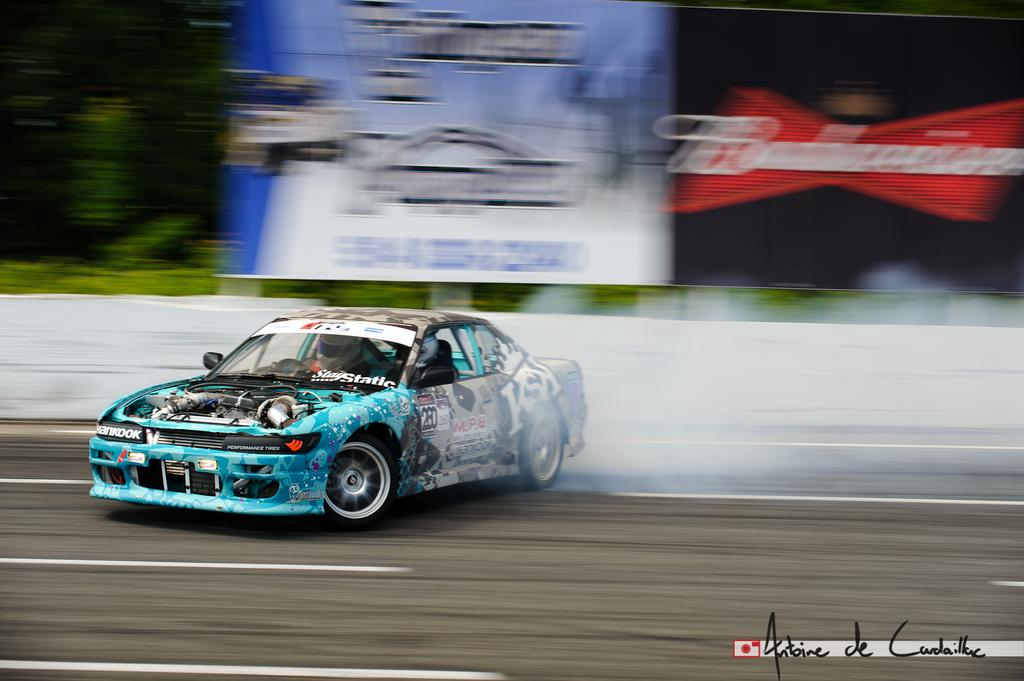What is the main subject of the image? The main subject of the image is a road. What is happening on the road? There is a person riding a car on the road. What can be seen in the background of the image? There are hoardings visible in the background. What type of natural elements are present in the image? There are trees present in the image. Where is the road located in the image? The road is at the bottom of the image. What type of cloth is draped over the trees in the image? There is no cloth draped over the trees in the image; only trees are present. What is the angle of the slope on the road in the image? The image does not depict a slope on the road; it is a flat road. 